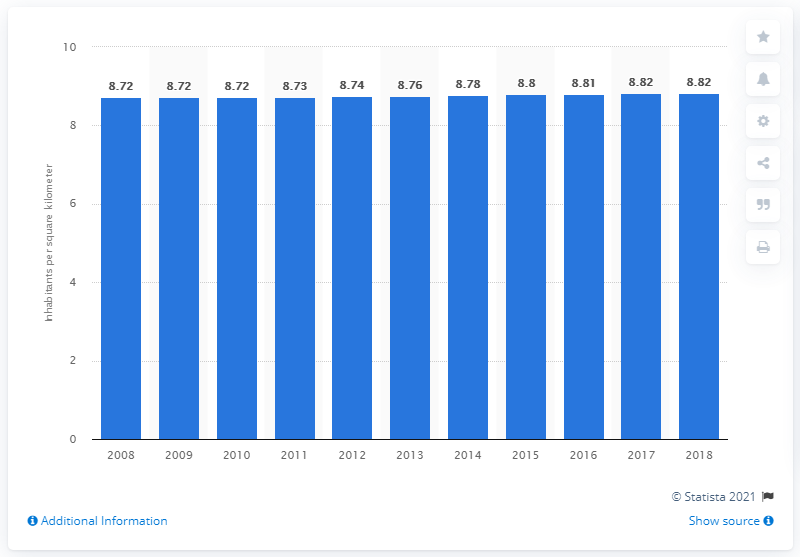Highlight a few significant elements in this photo. In 2018, the population density in Russia was approximately 8.82 people per square kilometer. 